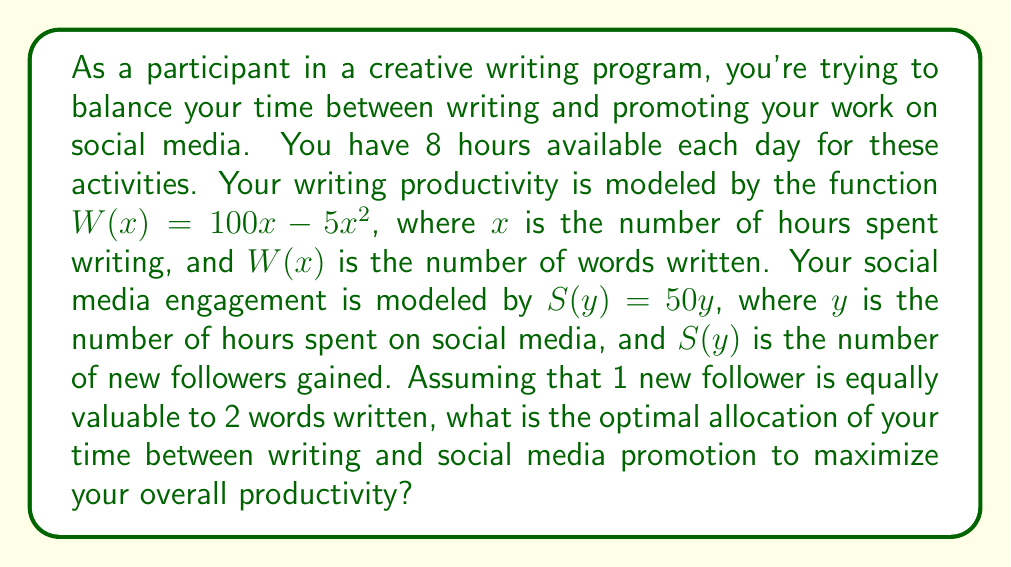Provide a solution to this math problem. Let's approach this problem step-by-step:

1) First, we need to set up our constraint equation. Since the total time available is 8 hours:

   $x + y = 8$

2) Now, we need to create an objective function that combines the value of writing and social media promotion. Let's call this function $P$ for productivity:

   $P = W(x) + 0.5S(y)$

   The 0.5 factor for $S(y)$ is because 1 follower is worth 2 words, so we divide the follower value by 2 to make it equivalent to words.

3) Substituting our given functions:

   $P = (100x - 5x^2) + 0.5(50y)$

4) We can substitute $y = 8 - x$ from our constraint equation:

   $P = (100x - 5x^2) + 0.5(50(8-x))$
   $P = 100x - 5x^2 + 200 - 25x$
   $P = -5x^2 + 75x + 200$

5) To find the maximum value of this quadratic function, we need to find where its derivative equals zero:

   $\frac{dP}{dx} = -10x + 75 = 0$
   $10x = 75$
   $x = 7.5$

6) The second derivative is negative ($-10$), confirming this is a maximum.

7) Since $x$ represents hours and can't be a fraction in this context, we need to check the integer values on either side: 7 and 8.

   For $x = 7$: $P = -5(7)^2 + 75(7) + 200 = 655$
   For $x = 8$: $P = -5(8)^2 + 75(8) + 200 = 640$

8) Therefore, the optimal allocation is 7 hours for writing and 1 hour for social media promotion.
Answer: The optimal allocation is 7 hours for writing and 1 hour for social media promotion, resulting in a productivity value of 655 (in word-equivalent units). 